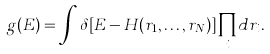<formula> <loc_0><loc_0><loc_500><loc_500>g ( E ) = \int \delta [ E - H ( { r } _ { 1 } , \dots , { r } _ { N } ) ] \prod _ { i } d { r } _ { i } .</formula> 